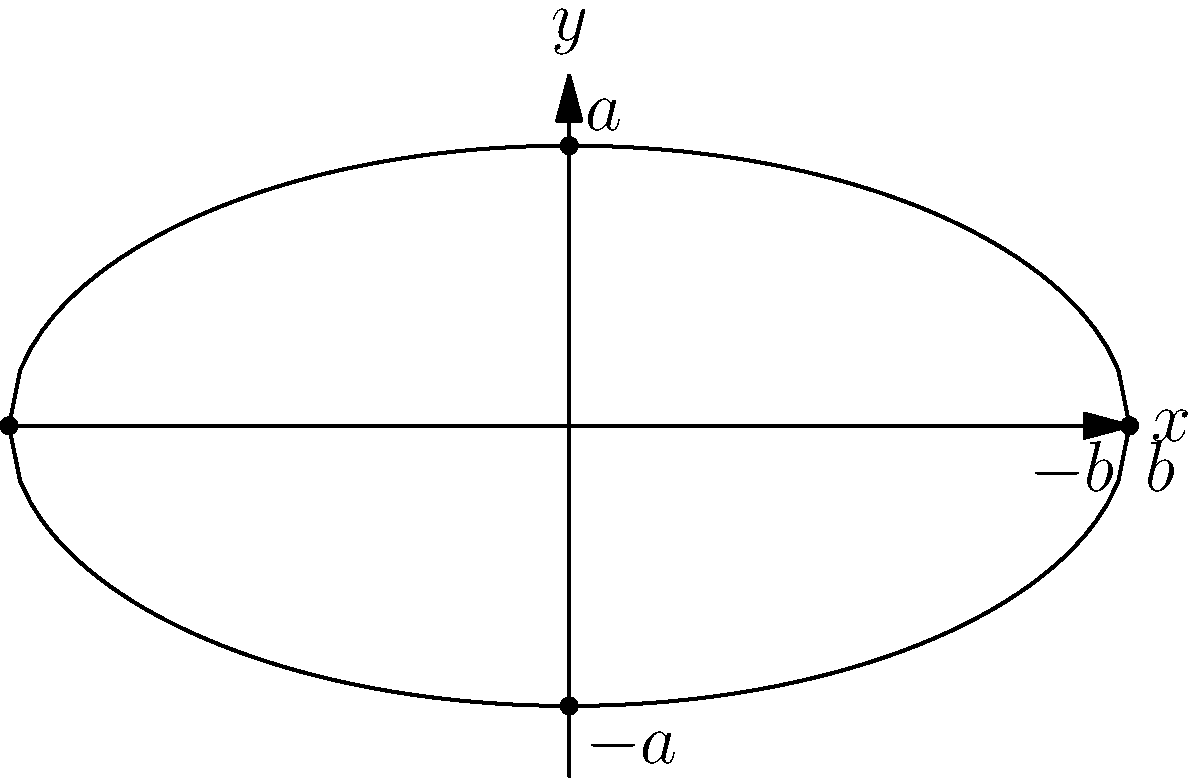A jazz club's roof is designed in the shape of an ellipse, as shown in the diagram. The roof spans 8 meters at its widest point (along the x-axis) and has a maximum height of 4 meters (along the y-axis). What is the equation of this elliptical roof, and what is its eccentricity? To solve this problem, we'll follow these steps:

1) The general equation of an ellipse centered at the origin is:

   $$\frac{x^2}{a^2} + \frac{y^2}{b^2} = 1$$

   where $a$ is the length of the semi-major axis and $b$ is the length of the semi-minor axis.

2) From the given information:
   - The width is 8 meters, so $2b = 8$, or $b = 4$
   - The height is 4 meters, so $2a = 4$, or $a = 2$

3) Substituting these values into the general equation:

   $$\frac{x^2}{4^2} + \frac{y^2}{2^2} = 1$$

4) Simplifying:

   $$\frac{x^2}{16} + \frac{y^2}{4} = 1$$

5) To find the eccentricity, we use the formula:

   $$e = \sqrt{1 - \frac{b^2}{a^2}}$$

   where $a$ is the semi-major axis (in this case, the vertical axis) and $b$ is the semi-minor axis.

6) Substituting the values:

   $$e = \sqrt{1 - \frac{4^2}{2^2}} = \sqrt{1 - 4} = \sqrt{-3}$$

7) Since the eccentricity is the square root of a negative number, this indicates that our initial assumption about which axis was major and which was minor was incorrect. We need to swap $a$ and $b$:

   $$e = \sqrt{1 - \frac{2^2}{4^2}} = \sqrt{1 - \frac{1}{4}} = \sqrt{\frac{3}{4}} = \frac{\sqrt{3}}{2} \approx 0.866$$
Answer: Equation: $\frac{x^2}{16} + \frac{y^2}{4} = 1$, Eccentricity: $\frac{\sqrt{3}}{2}$ 